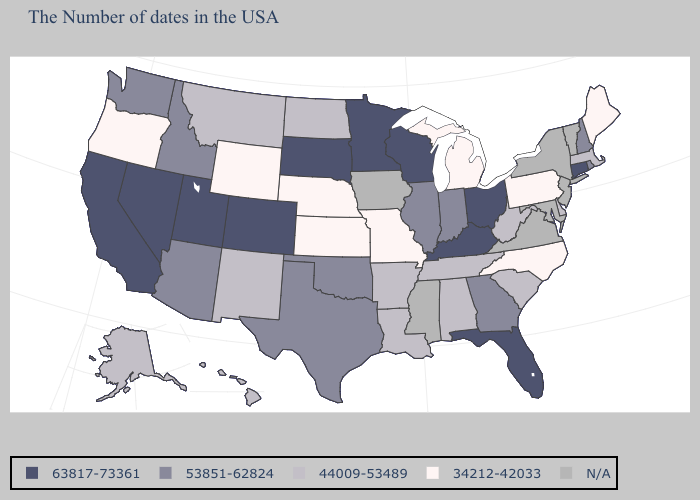Which states have the lowest value in the West?
Keep it brief. Wyoming, Oregon. Among the states that border Louisiana , which have the lowest value?
Concise answer only. Arkansas. What is the value of California?
Keep it brief. 63817-73361. What is the value of Louisiana?
Keep it brief. 44009-53489. Which states have the lowest value in the USA?
Be succinct. Maine, Pennsylvania, North Carolina, Michigan, Missouri, Kansas, Nebraska, Wyoming, Oregon. Name the states that have a value in the range 63817-73361?
Short answer required. Connecticut, Ohio, Florida, Kentucky, Wisconsin, Minnesota, South Dakota, Colorado, Utah, Nevada, California. Name the states that have a value in the range 34212-42033?
Keep it brief. Maine, Pennsylvania, North Carolina, Michigan, Missouri, Kansas, Nebraska, Wyoming, Oregon. What is the highest value in the West ?
Concise answer only. 63817-73361. Does the map have missing data?
Answer briefly. Yes. Among the states that border Arizona , does Utah have the lowest value?
Quick response, please. No. Does Kansas have the highest value in the MidWest?
Concise answer only. No. 